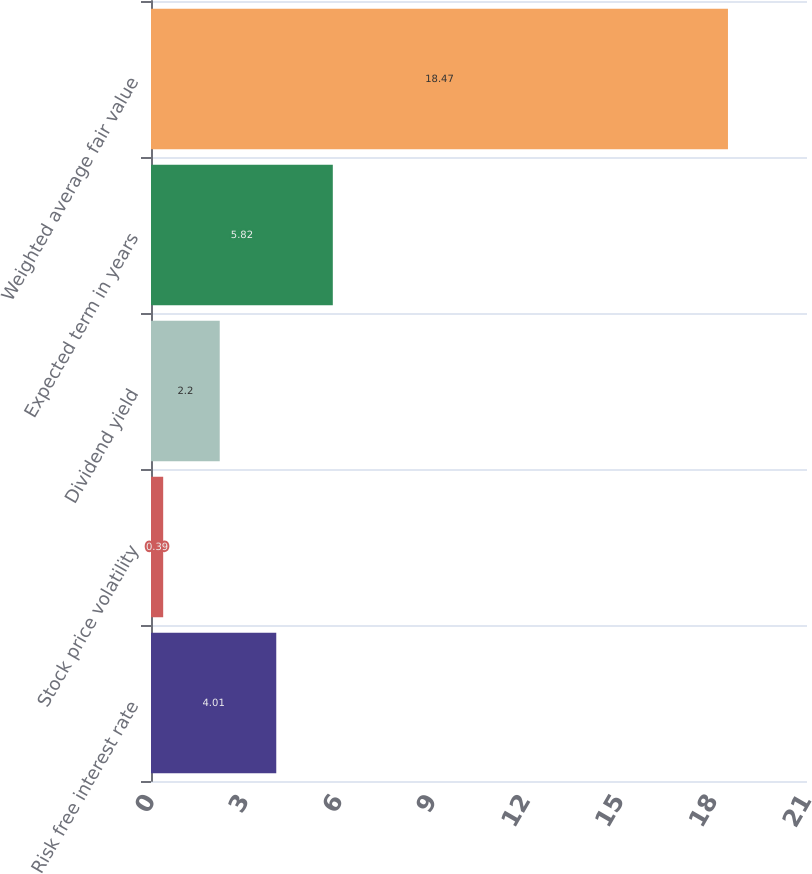Convert chart. <chart><loc_0><loc_0><loc_500><loc_500><bar_chart><fcel>Risk free interest rate<fcel>Stock price volatility<fcel>Dividend yield<fcel>Expected term in years<fcel>Weighted average fair value<nl><fcel>4.01<fcel>0.39<fcel>2.2<fcel>5.82<fcel>18.47<nl></chart> 